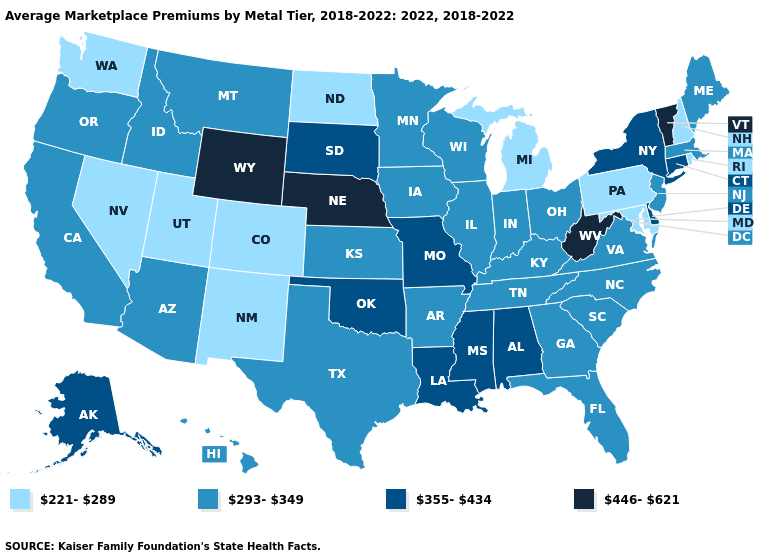What is the value of Nevada?
Quick response, please. 221-289. Name the states that have a value in the range 355-434?
Be succinct. Alabama, Alaska, Connecticut, Delaware, Louisiana, Mississippi, Missouri, New York, Oklahoma, South Dakota. What is the value of Delaware?
Short answer required. 355-434. Does Mississippi have the highest value in the USA?
Write a very short answer. No. How many symbols are there in the legend?
Concise answer only. 4. What is the value of Wyoming?
Write a very short answer. 446-621. What is the value of Arkansas?
Write a very short answer. 293-349. Name the states that have a value in the range 221-289?
Give a very brief answer. Colorado, Maryland, Michigan, Nevada, New Hampshire, New Mexico, North Dakota, Pennsylvania, Rhode Island, Utah, Washington. Does New Hampshire have the lowest value in the Northeast?
Be succinct. Yes. What is the value of Florida?
Keep it brief. 293-349. What is the value of Maryland?
Be succinct. 221-289. Name the states that have a value in the range 293-349?
Quick response, please. Arizona, Arkansas, California, Florida, Georgia, Hawaii, Idaho, Illinois, Indiana, Iowa, Kansas, Kentucky, Maine, Massachusetts, Minnesota, Montana, New Jersey, North Carolina, Ohio, Oregon, South Carolina, Tennessee, Texas, Virginia, Wisconsin. What is the value of Iowa?
Answer briefly. 293-349. Among the states that border Louisiana , does Arkansas have the highest value?
Keep it brief. No. What is the lowest value in states that border Maryland?
Short answer required. 221-289. 